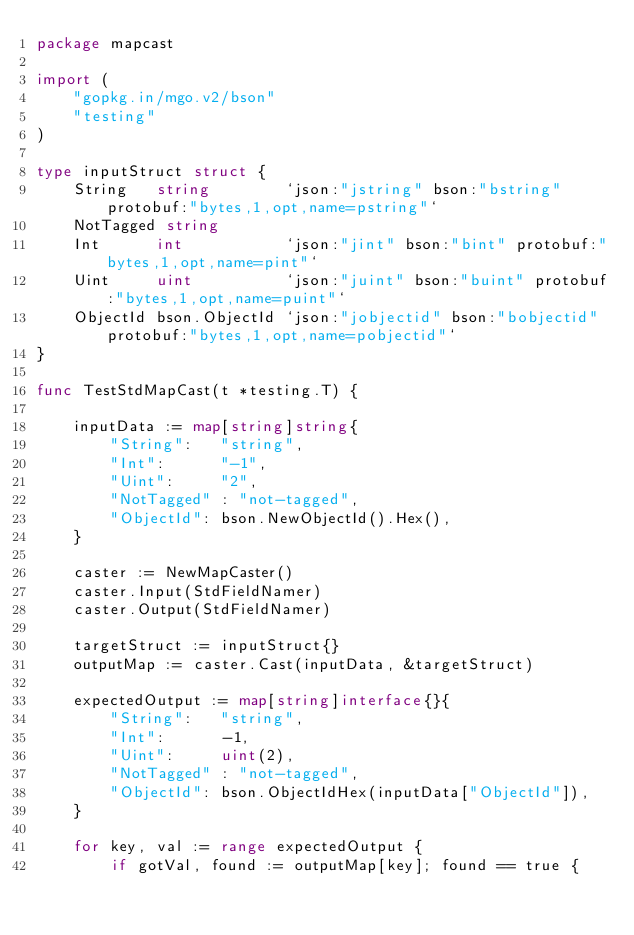<code> <loc_0><loc_0><loc_500><loc_500><_Go_>package mapcast

import (
	"gopkg.in/mgo.v2/bson"
	"testing"
)

type inputStruct struct {
	String   string        `json:"jstring" bson:"bstring" protobuf:"bytes,1,opt,name=pstring"`
	NotTagged string
	Int      int           `json:"jint" bson:"bint" protobuf:"bytes,1,opt,name=pint"`
	Uint     uint          `json:"juint" bson:"buint" protobuf:"bytes,1,opt,name=puint"`
	ObjectId bson.ObjectId `json:"jobjectid" bson:"bobjectid" protobuf:"bytes,1,opt,name=pobjectid"`
}

func TestStdMapCast(t *testing.T) {

	inputData := map[string]string{
		"String":   "string",
		"Int":      "-1",
		"Uint":     "2",
		"NotTagged" : "not-tagged",
		"ObjectId": bson.NewObjectId().Hex(),
	}

	caster := NewMapCaster()
	caster.Input(StdFieldNamer)
	caster.Output(StdFieldNamer)

	targetStruct := inputStruct{}
	outputMap := caster.Cast(inputData, &targetStruct)

	expectedOutput := map[string]interface{}{
		"String":   "string",
		"Int":      -1,
		"Uint":     uint(2),
		"NotTagged" : "not-tagged",
		"ObjectId": bson.ObjectIdHex(inputData["ObjectId"]),
	}

	for key, val := range expectedOutput {
		if gotVal, found := outputMap[key]; found == true {</code> 